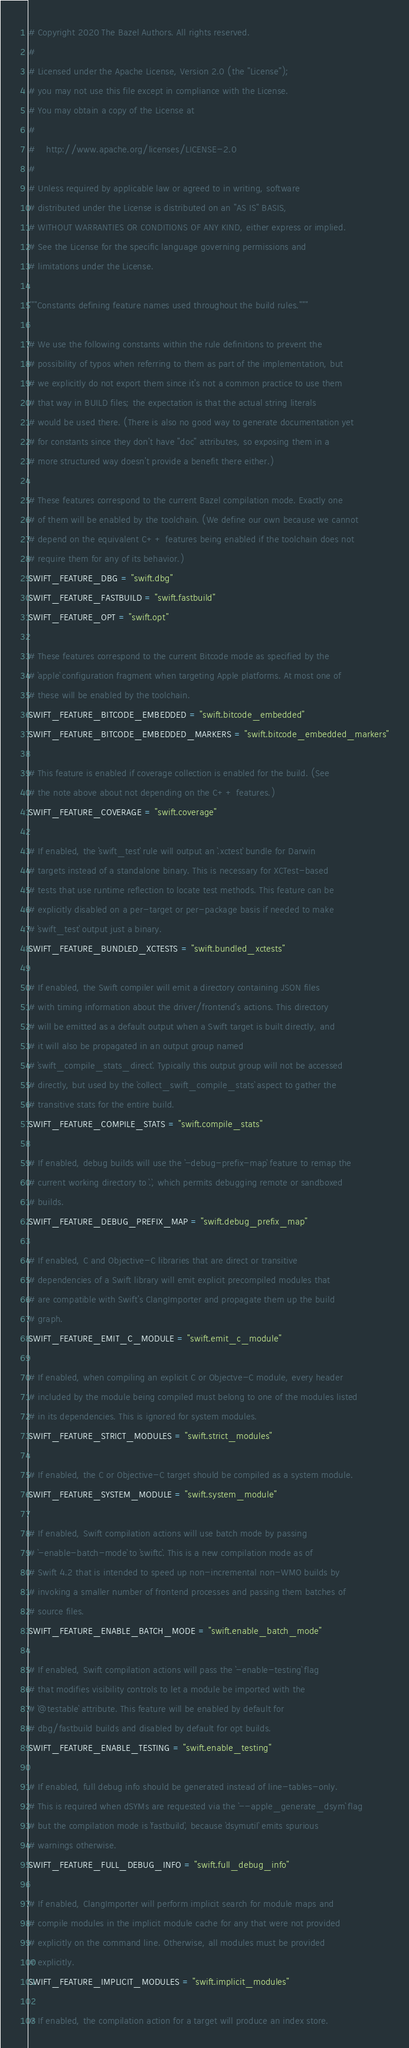<code> <loc_0><loc_0><loc_500><loc_500><_Python_># Copyright 2020 The Bazel Authors. All rights reserved.
#
# Licensed under the Apache License, Version 2.0 (the "License");
# you may not use this file except in compliance with the License.
# You may obtain a copy of the License at
#
#    http://www.apache.org/licenses/LICENSE-2.0
#
# Unless required by applicable law or agreed to in writing, software
# distributed under the License is distributed on an "AS IS" BASIS,
# WITHOUT WARRANTIES OR CONDITIONS OF ANY KIND, either express or implied.
# See the License for the specific language governing permissions and
# limitations under the License.

"""Constants defining feature names used throughout the build rules."""

# We use the following constants within the rule definitions to prevent the
# possibility of typos when referring to them as part of the implementation, but
# we explicitly do not export them since it's not a common practice to use them
# that way in BUILD files; the expectation is that the actual string literals
# would be used there. (There is also no good way to generate documentation yet
# for constants since they don't have "doc" attributes, so exposing them in a
# more structured way doesn't provide a benefit there either.)

# These features correspond to the current Bazel compilation mode. Exactly one
# of them will be enabled by the toolchain. (We define our own because we cannot
# depend on the equivalent C++ features being enabled if the toolchain does not
# require them for any of its behavior.)
SWIFT_FEATURE_DBG = "swift.dbg"
SWIFT_FEATURE_FASTBUILD = "swift.fastbuild"
SWIFT_FEATURE_OPT = "swift.opt"

# These features correspond to the current Bitcode mode as specified by the
# `apple` configuration fragment when targeting Apple platforms. At most one of
# these will be enabled by the toolchain.
SWIFT_FEATURE_BITCODE_EMBEDDED = "swift.bitcode_embedded"
SWIFT_FEATURE_BITCODE_EMBEDDED_MARKERS = "swift.bitcode_embedded_markers"

# This feature is enabled if coverage collection is enabled for the build. (See
# the note above about not depending on the C++ features.)
SWIFT_FEATURE_COVERAGE = "swift.coverage"

# If enabled, the `swift_test` rule will output an `.xctest` bundle for Darwin
# targets instead of a standalone binary. This is necessary for XCTest-based
# tests that use runtime reflection to locate test methods. This feature can be
# explicitly disabled on a per-target or per-package basis if needed to make
# `swift_test` output just a binary.
SWIFT_FEATURE_BUNDLED_XCTESTS = "swift.bundled_xctests"

# If enabled, the Swift compiler will emit a directory containing JSON files
# with timing information about the driver/frontend's actions. This directory
# will be emitted as a default output when a Swift target is built directly, and
# it will also be propagated in an output group named
# `swift_compile_stats_direct`. Typically this output group will not be accessed
# directly, but used by the `collect_swift_compile_stats` aspect to gather the
# transitive stats for the entire build.
SWIFT_FEATURE_COMPILE_STATS = "swift.compile_stats"

# If enabled, debug builds will use the `-debug-prefix-map` feature to remap the
# current working directory to `.`, which permits debugging remote or sandboxed
# builds.
SWIFT_FEATURE_DEBUG_PREFIX_MAP = "swift.debug_prefix_map"

# If enabled, C and Objective-C libraries that are direct or transitive
# dependencies of a Swift library will emit explicit precompiled modules that
# are compatible with Swift's ClangImporter and propagate them up the build
# graph.
SWIFT_FEATURE_EMIT_C_MODULE = "swift.emit_c_module"

# If enabled, when compiling an explicit C or Objectve-C module, every header
# included by the module being compiled must belong to one of the modules listed
# in its dependencies. This is ignored for system modules.
SWIFT_FEATURE_STRICT_MODULES = "swift.strict_modules"

# If enabled, the C or Objective-C target should be compiled as a system module.
SWIFT_FEATURE_SYSTEM_MODULE = "swift.system_module"

# If enabled, Swift compilation actions will use batch mode by passing
# `-enable-batch-mode` to `swiftc`. This is a new compilation mode as of
# Swift 4.2 that is intended to speed up non-incremental non-WMO builds by
# invoking a smaller number of frontend processes and passing them batches of
# source files.
SWIFT_FEATURE_ENABLE_BATCH_MODE = "swift.enable_batch_mode"

# If enabled, Swift compilation actions will pass the `-enable-testing` flag
# that modifies visibility controls to let a module be imported with the
# `@testable` attribute. This feature will be enabled by default for
# dbg/fastbuild builds and disabled by default for opt builds.
SWIFT_FEATURE_ENABLE_TESTING = "swift.enable_testing"

# If enabled, full debug info should be generated instead of line-tables-only.
# This is required when dSYMs are requested via the `--apple_generate_dsym` flag
# but the compilation mode is `fastbuild`, because `dsymutil` emits spurious
# warnings otherwise.
SWIFT_FEATURE_FULL_DEBUG_INFO = "swift.full_debug_info"

# If enabled, ClangImporter will perform implicit search for module maps and
# compile modules in the implicit module cache for any that were not provided
# explicitly on the command line. Otherwise, all modules must be provided
# explicitly.
SWIFT_FEATURE_IMPLICIT_MODULES = "swift.implicit_modules"

# If enabled, the compilation action for a target will produce an index store.</code> 